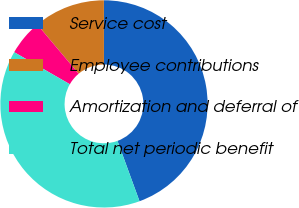Convert chart. <chart><loc_0><loc_0><loc_500><loc_500><pie_chart><fcel>Service cost<fcel>Employee contributions<fcel>Amortization and deferral of<fcel>Total net periodic benefit<nl><fcel>44.44%<fcel>11.11%<fcel>5.56%<fcel>38.89%<nl></chart> 